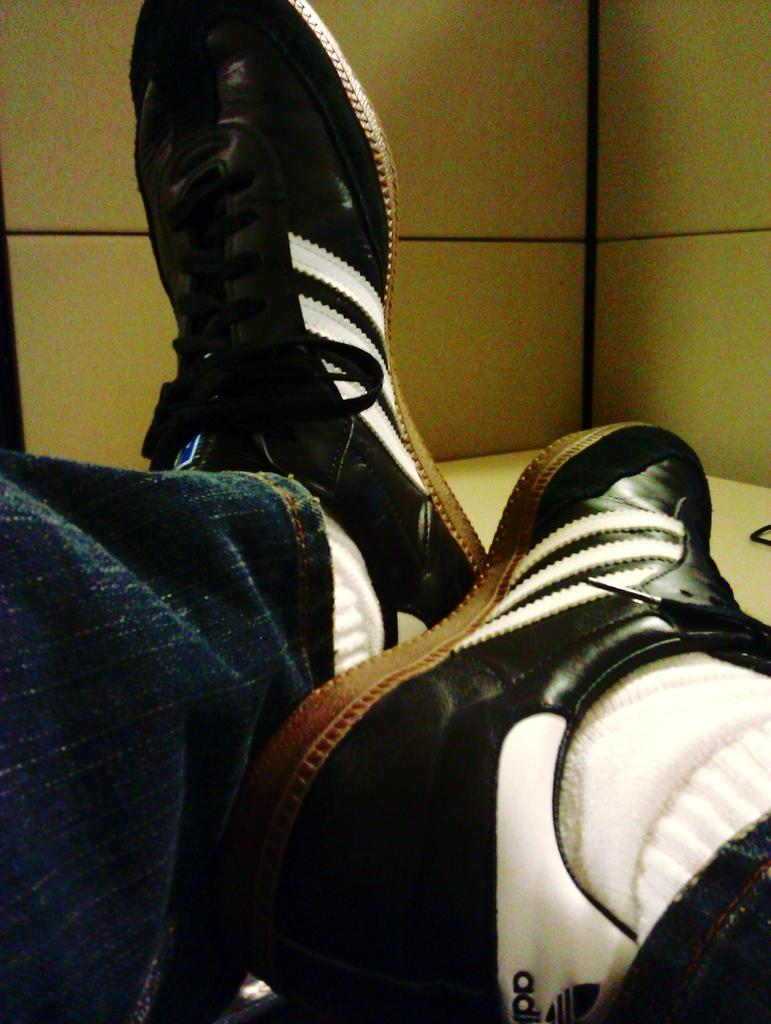What can be seen in the foreground of the image? There are two legs of a person in the foreground of the image. What type of footwear is the person wearing? The person is wearing black shoes. Where are the legs resting? The legs are resting on a table. What is visible in the background of the image? There is a wall in the background of the image. What type of juice is being served on the table next to the person's legs? There is no juice present in the image; it only shows the person's legs resting on a table. 